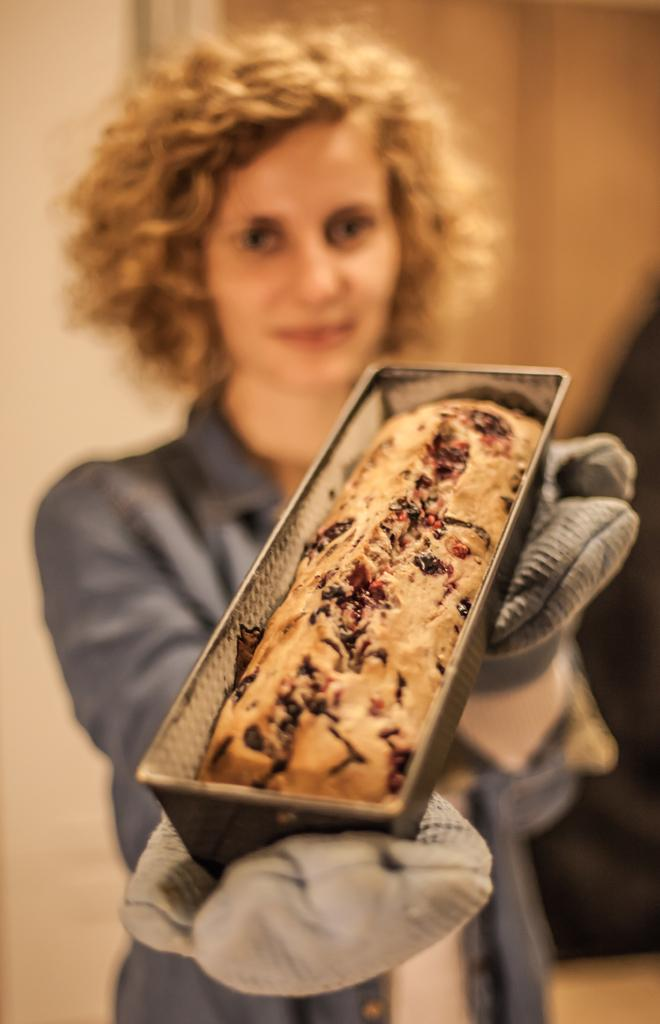Who is present in the image? There is a woman in the image. What is the woman wearing on her hands? The woman is wearing gloves. What is the woman holding in the image? The woman is holding a box. What is inside the box that the woman is holding? There is a baked cake inside the box. What type of sleet can be seen falling on the canvas in the image? There is no sleet or canvas present in the image. 